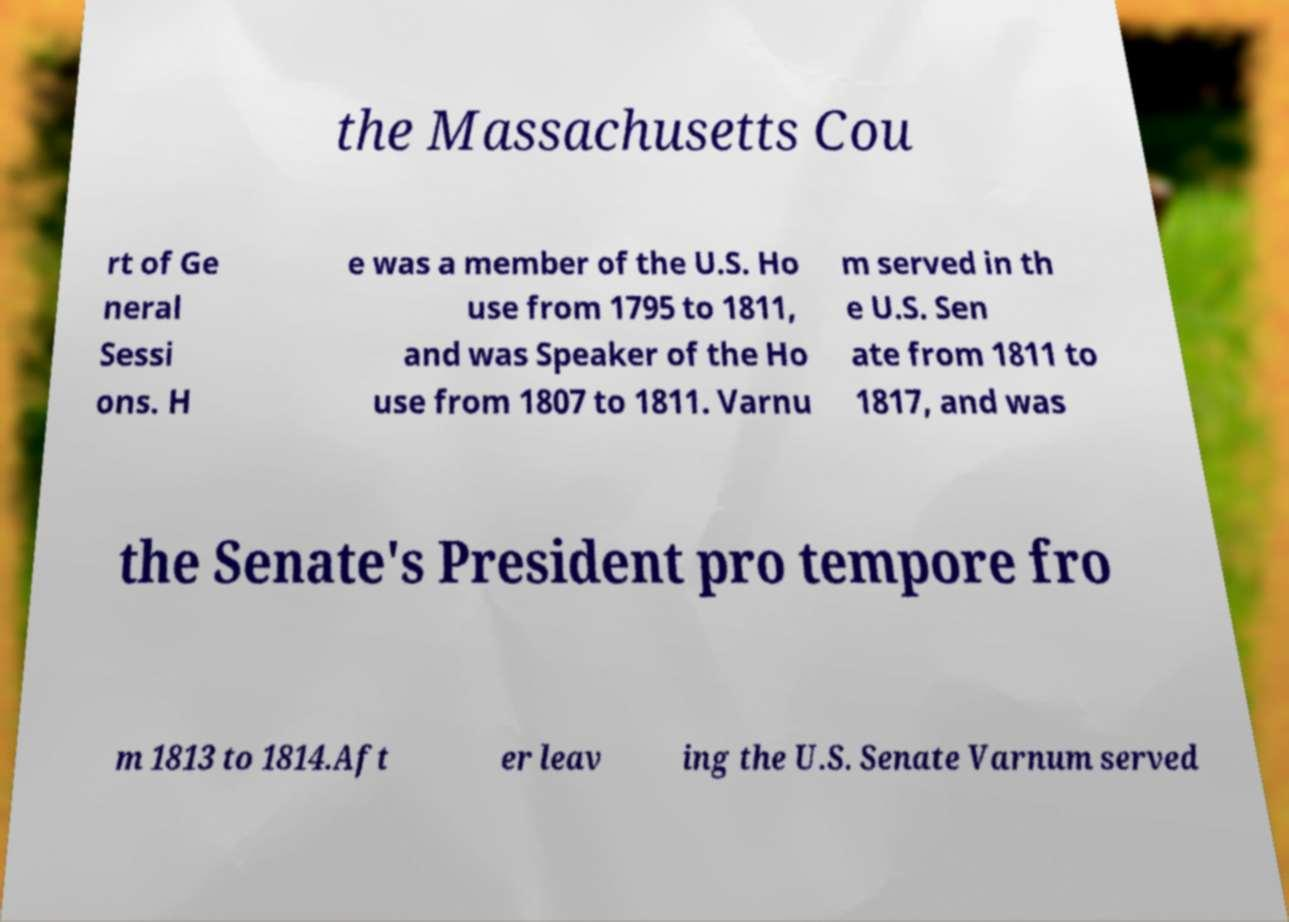Can you accurately transcribe the text from the provided image for me? the Massachusetts Cou rt of Ge neral Sessi ons. H e was a member of the U.S. Ho use from 1795 to 1811, and was Speaker of the Ho use from 1807 to 1811. Varnu m served in th e U.S. Sen ate from 1811 to 1817, and was the Senate's President pro tempore fro m 1813 to 1814.Aft er leav ing the U.S. Senate Varnum served 